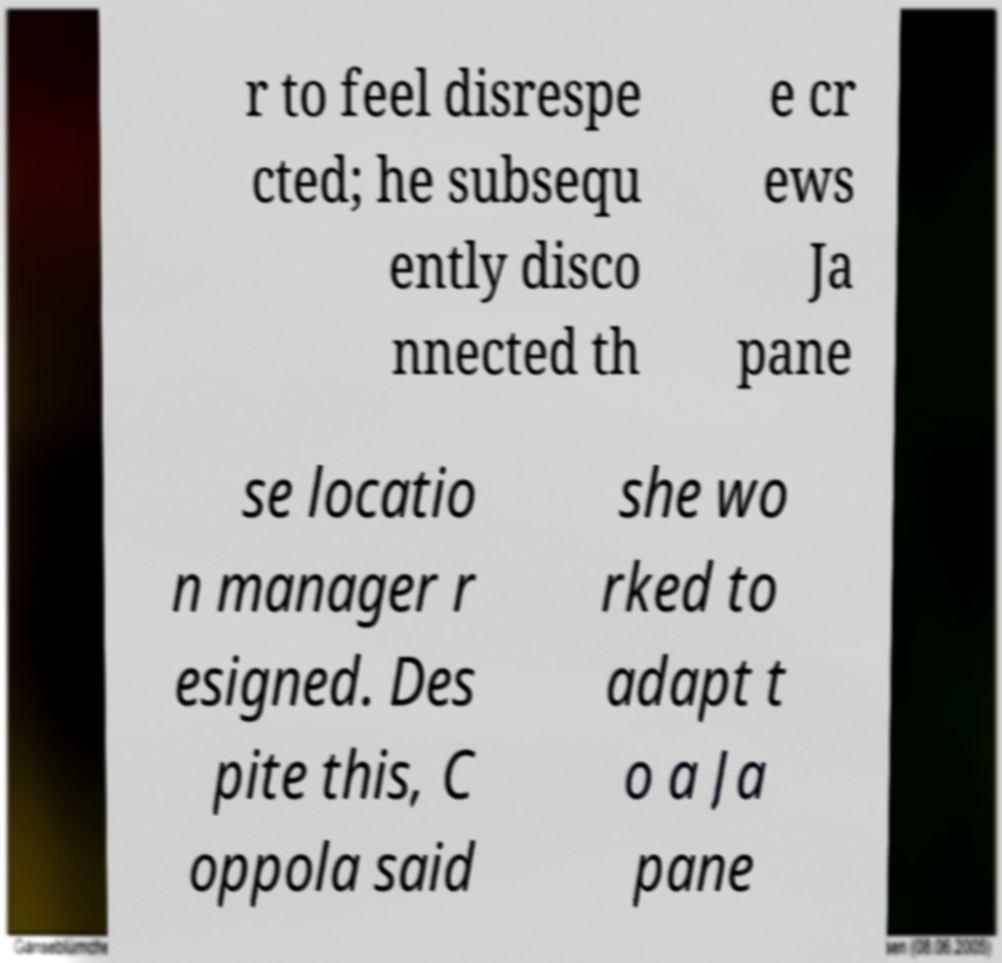For documentation purposes, I need the text within this image transcribed. Could you provide that? r to feel disrespe cted; he subsequ ently disco nnected th e cr ews Ja pane se locatio n manager r esigned. Des pite this, C oppola said she wo rked to adapt t o a Ja pane 